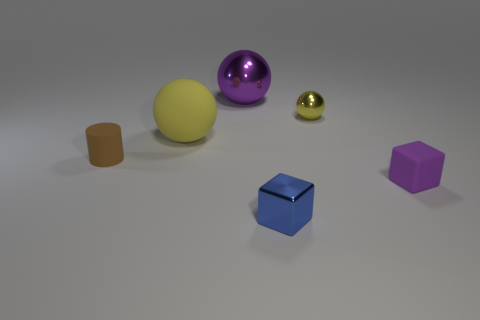The object that is in front of the tiny yellow shiny ball and behind the small brown cylinder is what color?
Keep it short and to the point. Yellow. Is there anything else that is the same size as the yellow shiny thing?
Your answer should be compact. Yes. There is a tiny metallic thing that is in front of the tiny brown rubber thing; is its color the same as the rubber cube?
Keep it short and to the point. No. How many cylinders are either small brown matte objects or rubber objects?
Offer a terse response. 1. There is a yellow object that is behind the big yellow thing; what is its shape?
Ensure brevity in your answer.  Sphere. There is a metallic thing that is in front of the tiny matte object that is left of the big ball in front of the yellow metallic object; what is its color?
Ensure brevity in your answer.  Blue. Does the small yellow object have the same material as the purple sphere?
Offer a terse response. Yes. How many brown things are either large rubber cylinders or rubber balls?
Provide a succinct answer. 0. There is a large rubber object; what number of brown things are in front of it?
Your answer should be very brief. 1. Is the number of small cylinders greater than the number of tiny gray blocks?
Your response must be concise. Yes. 